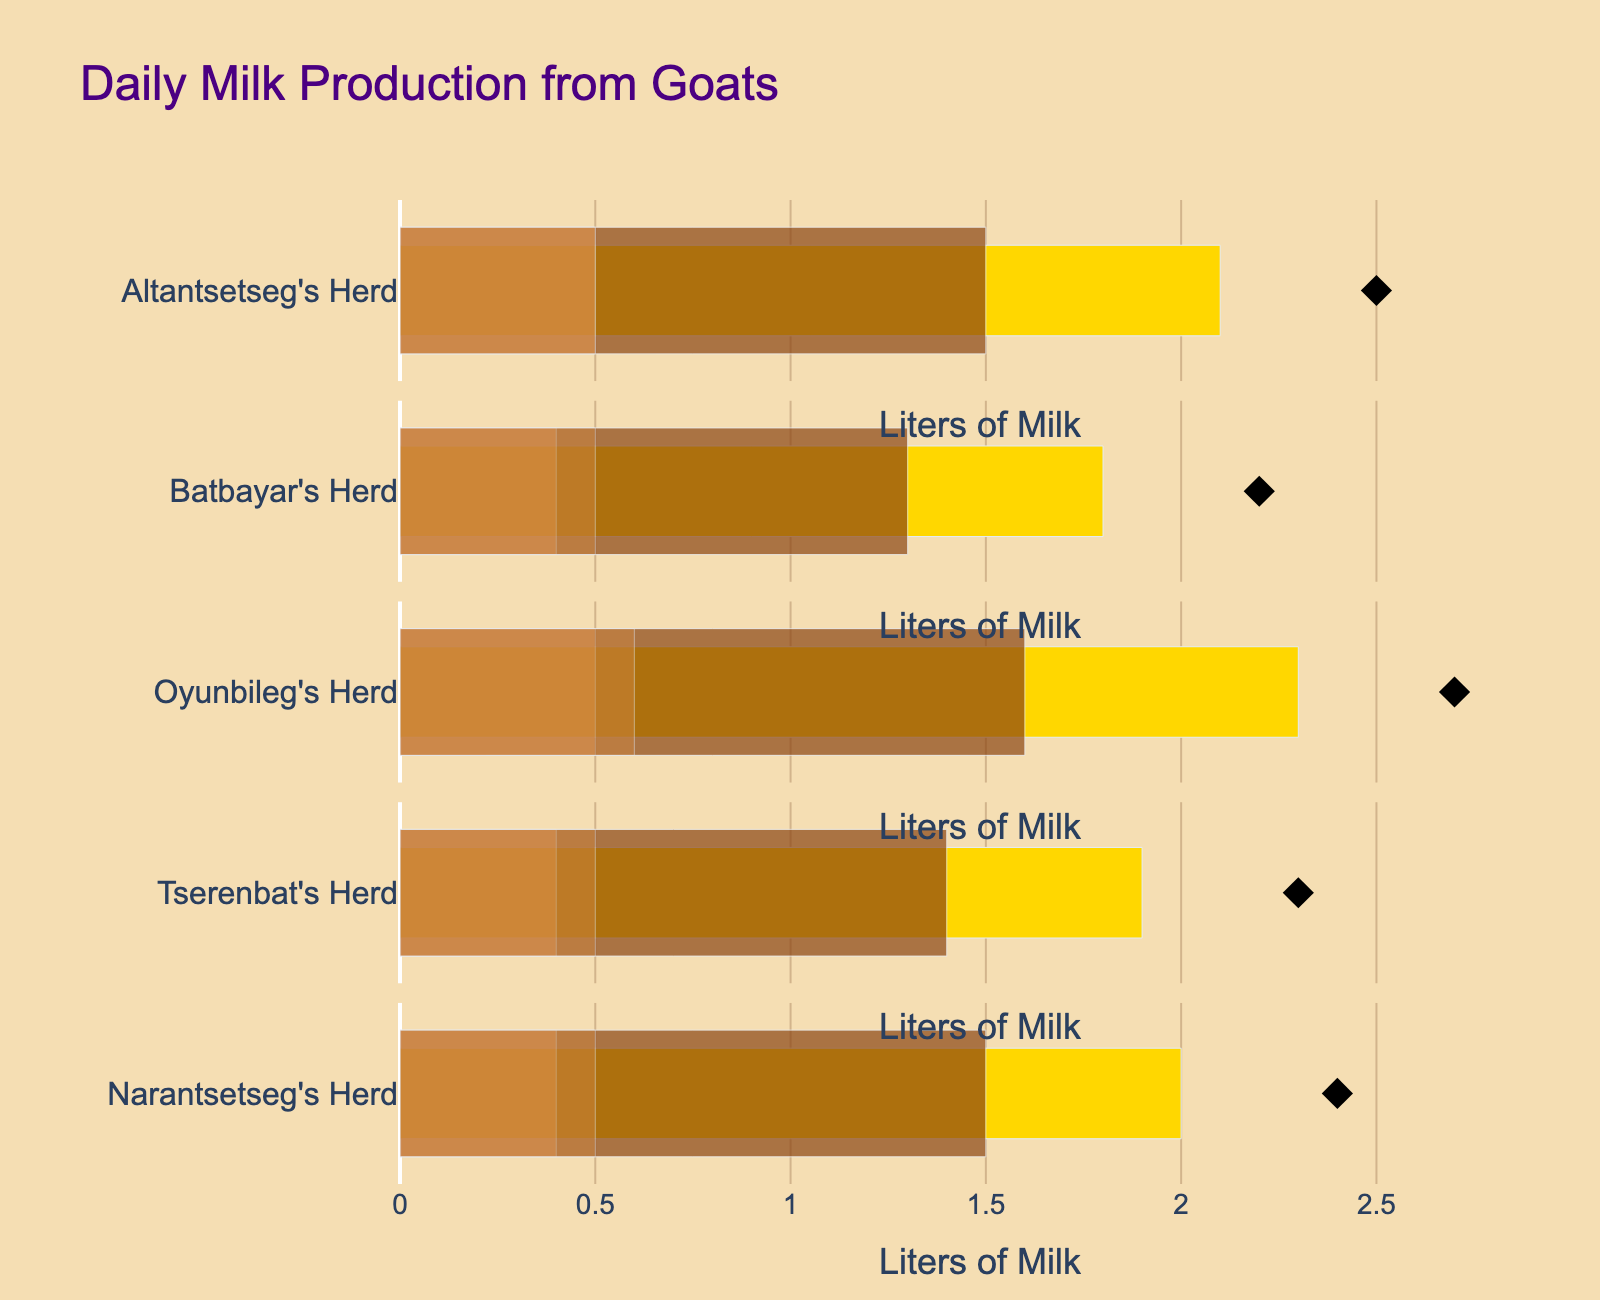What's the title of the figure? The title is displayed at the top of the chart in a larger font size and is typically the first text to be seen on the figure.
Answer: Daily Milk Production from Goats What is the color representation for 'Actual' milk production? The 'Actual' milk production is represented by a bar with a gold color, which stands out brightly among other colors.
Answer: Gold Which herds achieved their target milk production? We need to compare the 'Actual' value with the 'Target' value for each herd. Altantsetseg's Herd, Oyunbileg's Herd, and Narantsetseg's Herd have their 'Actual' values equal to or exceeding their 'Target' values.
Answer: Altantsetseg's Herd, Oyunbileg's Herd, and Narantsetseg's Herd How many herds were evaluated in total? Count the number of herds listed on the y-axis of the figure.
Answer: 5 herds Which herd has the highest 'Actual' milk production? Compare the 'Actual' values of each herd and find the maximum. Oyunbileg's Herd has the highest 'Actual' value at 2.3 liters.
Answer: Oyunbileg's Herd For Tserenbat's Herd, how much more milk production is needed to meet the 'Target'? Subtract the 'Actual' value from the 'Target' value for Tserenbat's Herd. The 'Target' is 2.3 liters and the 'Actual' is 1.9 liters. Therefore, 2.3 - 1.9 = 0.4 liters more is needed.
Answer: 0.4 liters What are the satisfactory ranges for Altantsetseg's Herd and Batbayar's Herd? The satisfactory range for each herd is provided in the data under 'Satisfactory' and 'Good' categories. For Altantsetseg's Herd, it is between 2.0 and 2.5 liters. For Batbayar's Herd, it is between 1.8 and 2.2 liters.
Answer: Altantsetseg's Herd: 2.0-2.5 liters, Batbayar's Herd: 1.8-2.2 liters Which herd has a 'Poor' threshold lower than 1.6 liters? Check the 'Poor' values for each herd. Batbayar's Herd and Tserenbat's Herd have 'Poor' thresholds lower than 1.6 liters.
Answer: Batbayar's Herd and Tserenbat's Herd Compare the 'Target' values of Narantsetseg's Herd and Altantsetseg’s Herd. Which one is greater? Comparing the 'Target' values: Narantsetseg’s Herd has a 'Target' of 2.4 liters, and Altantsetseg's Herd has a 'Target' of 2.5 liters. Thus, Altantsetseg’s Herd's target is greater.
Answer: Altantsetseg's Herd What can you infer about the performance of all herds based on the color representations? The colors and their opacity levels indicate different performance levels. The gold bar shows the 'Actual' production, while the gradient colors represent 'Poor', 'Satisfactory', and 'Good' ranges. Several herds fall within or exceed satisfactory ranges, indicating a generally positive performance against breed-specific targets.
Answer: Generally positive performance 